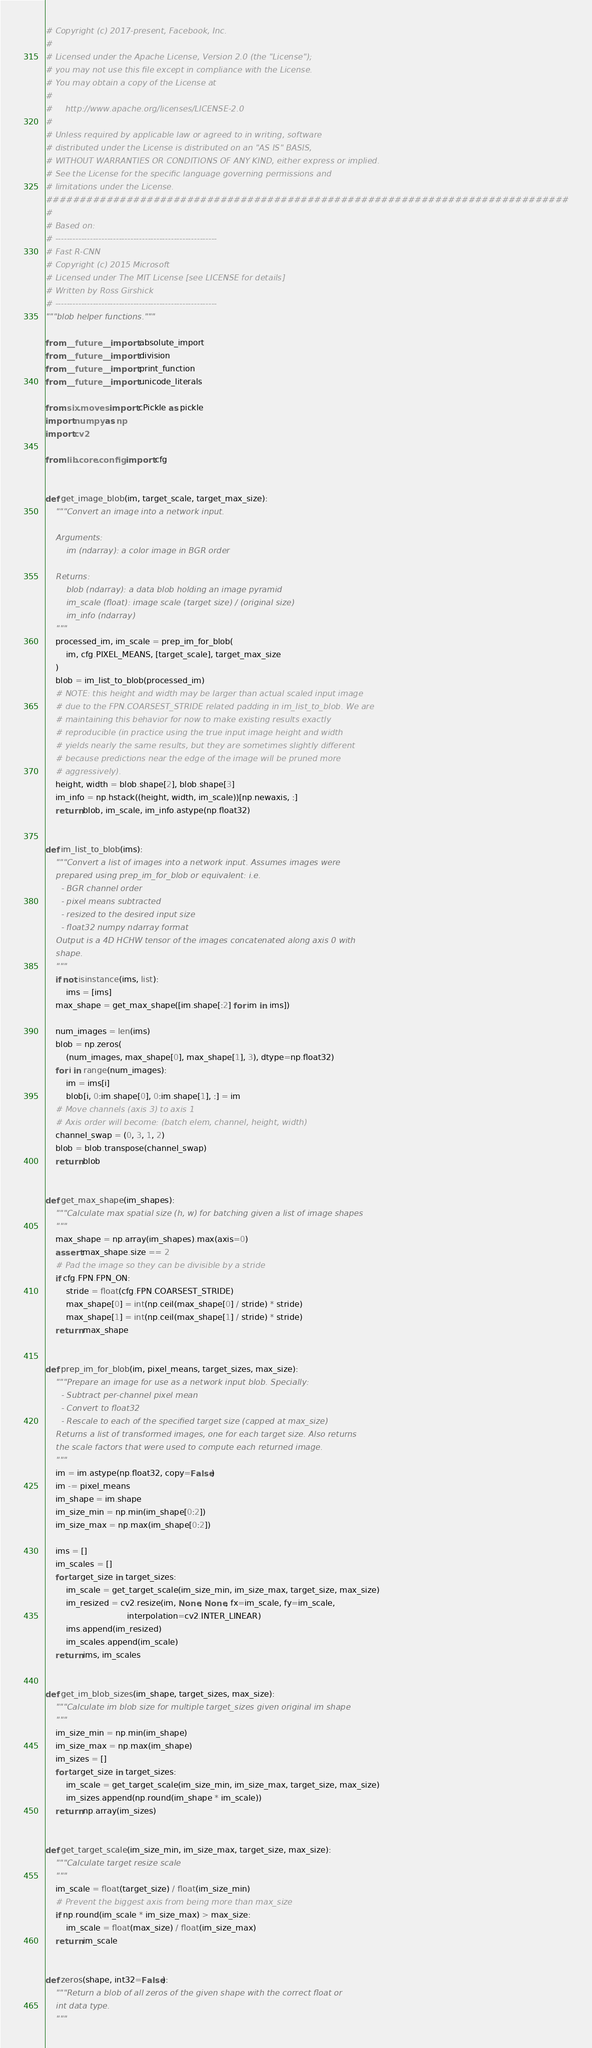Convert code to text. <code><loc_0><loc_0><loc_500><loc_500><_Python_># Copyright (c) 2017-present, Facebook, Inc.
#
# Licensed under the Apache License, Version 2.0 (the "License");
# you may not use this file except in compliance with the License.
# You may obtain a copy of the License at
#
#     http://www.apache.org/licenses/LICENSE-2.0
#
# Unless required by applicable law or agreed to in writing, software
# distributed under the License is distributed on an "AS IS" BASIS,
# WITHOUT WARRANTIES OR CONDITIONS OF ANY KIND, either express or implied.
# See the License for the specific language governing permissions and
# limitations under the License.
##############################################################################
#
# Based on:
# --------------------------------------------------------
# Fast R-CNN
# Copyright (c) 2015 Microsoft
# Licensed under The MIT License [see LICENSE for details]
# Written by Ross Girshick
# --------------------------------------------------------
"""blob helper functions."""

from __future__ import absolute_import
from __future__ import division
from __future__ import print_function
from __future__ import unicode_literals

from six.moves import cPickle as pickle
import numpy as np
import cv2

from lib.core.config import cfg


def get_image_blob(im, target_scale, target_max_size):
    """Convert an image into a network input.

    Arguments:
        im (ndarray): a color image in BGR order

    Returns:
        blob (ndarray): a data blob holding an image pyramid
        im_scale (float): image scale (target size) / (original size)
        im_info (ndarray)
    """
    processed_im, im_scale = prep_im_for_blob(
        im, cfg.PIXEL_MEANS, [target_scale], target_max_size
    )
    blob = im_list_to_blob(processed_im)
    # NOTE: this height and width may be larger than actual scaled input image
    # due to the FPN.COARSEST_STRIDE related padding in im_list_to_blob. We are
    # maintaining this behavior for now to make existing results exactly
    # reproducible (in practice using the true input image height and width
    # yields nearly the same results, but they are sometimes slightly different
    # because predictions near the edge of the image will be pruned more
    # aggressively).
    height, width = blob.shape[2], blob.shape[3]
    im_info = np.hstack((height, width, im_scale))[np.newaxis, :]
    return blob, im_scale, im_info.astype(np.float32)


def im_list_to_blob(ims):
    """Convert a list of images into a network input. Assumes images were
    prepared using prep_im_for_blob or equivalent: i.e.
      - BGR channel order
      - pixel means subtracted
      - resized to the desired input size
      - float32 numpy ndarray format
    Output is a 4D HCHW tensor of the images concatenated along axis 0 with
    shape.
    """
    if not isinstance(ims, list):
        ims = [ims]
    max_shape = get_max_shape([im.shape[:2] for im in ims])

    num_images = len(ims)
    blob = np.zeros(
        (num_images, max_shape[0], max_shape[1], 3), dtype=np.float32)
    for i in range(num_images):
        im = ims[i]
        blob[i, 0:im.shape[0], 0:im.shape[1], :] = im
    # Move channels (axis 3) to axis 1
    # Axis order will become: (batch elem, channel, height, width)
    channel_swap = (0, 3, 1, 2)
    blob = blob.transpose(channel_swap)
    return blob


def get_max_shape(im_shapes):
    """Calculate max spatial size (h, w) for batching given a list of image shapes
    """
    max_shape = np.array(im_shapes).max(axis=0)
    assert max_shape.size == 2
    # Pad the image so they can be divisible by a stride
    if cfg.FPN.FPN_ON:
        stride = float(cfg.FPN.COARSEST_STRIDE)
        max_shape[0] = int(np.ceil(max_shape[0] / stride) * stride)
        max_shape[1] = int(np.ceil(max_shape[1] / stride) * stride)
    return max_shape


def prep_im_for_blob(im, pixel_means, target_sizes, max_size):
    """Prepare an image for use as a network input blob. Specially:
      - Subtract per-channel pixel mean
      - Convert to float32
      - Rescale to each of the specified target size (capped at max_size)
    Returns a list of transformed images, one for each target size. Also returns
    the scale factors that were used to compute each returned image.
    """
    im = im.astype(np.float32, copy=False)
    im -= pixel_means
    im_shape = im.shape
    im_size_min = np.min(im_shape[0:2])
    im_size_max = np.max(im_shape[0:2])

    ims = []
    im_scales = []
    for target_size in target_sizes:
        im_scale = get_target_scale(im_size_min, im_size_max, target_size, max_size)
        im_resized = cv2.resize(im, None, None, fx=im_scale, fy=im_scale,
                                interpolation=cv2.INTER_LINEAR)
        ims.append(im_resized)
        im_scales.append(im_scale)
    return ims, im_scales


def get_im_blob_sizes(im_shape, target_sizes, max_size):
    """Calculate im blob size for multiple target_sizes given original im shape
    """
    im_size_min = np.min(im_shape)
    im_size_max = np.max(im_shape)
    im_sizes = []
    for target_size in target_sizes:
        im_scale = get_target_scale(im_size_min, im_size_max, target_size, max_size)
        im_sizes.append(np.round(im_shape * im_scale))
    return np.array(im_sizes)


def get_target_scale(im_size_min, im_size_max, target_size, max_size):
    """Calculate target resize scale
    """
    im_scale = float(target_size) / float(im_size_min)
    # Prevent the biggest axis from being more than max_size
    if np.round(im_scale * im_size_max) > max_size:
        im_scale = float(max_size) / float(im_size_max)
    return im_scale


def zeros(shape, int32=False):
    """Return a blob of all zeros of the given shape with the correct float or
    int data type.
    """</code> 